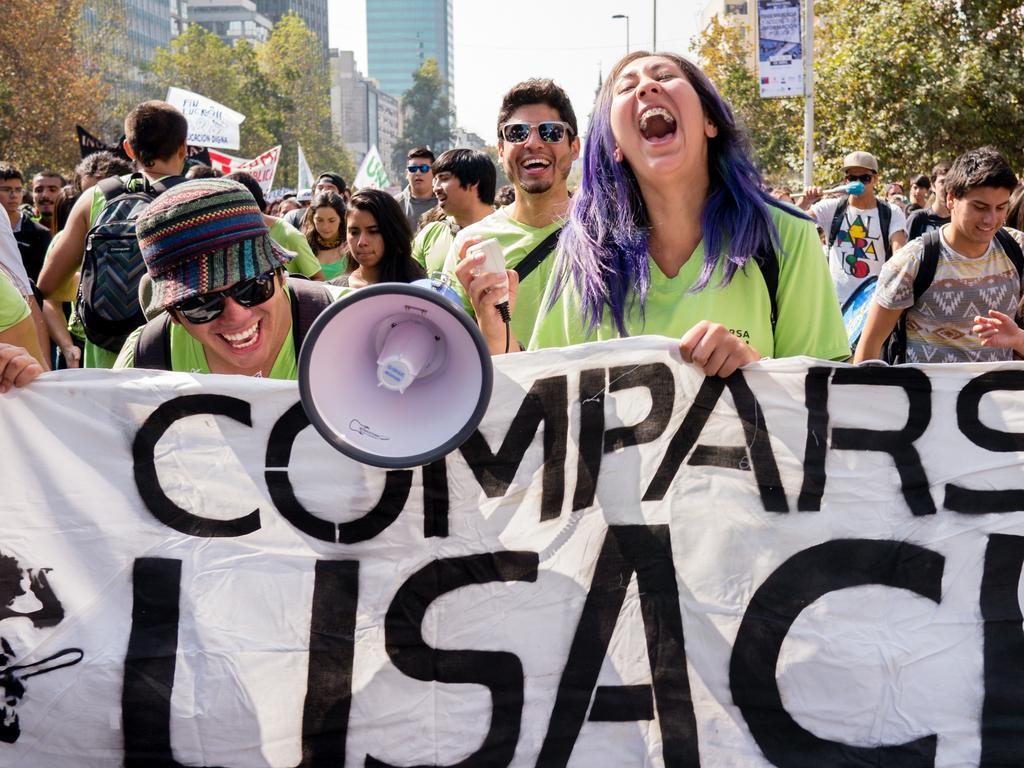Could you give a brief overview of what you see in this image? In this image we can see people, flags, horn speaker, poles, board, trees, and buildings. In the background there is sky. 